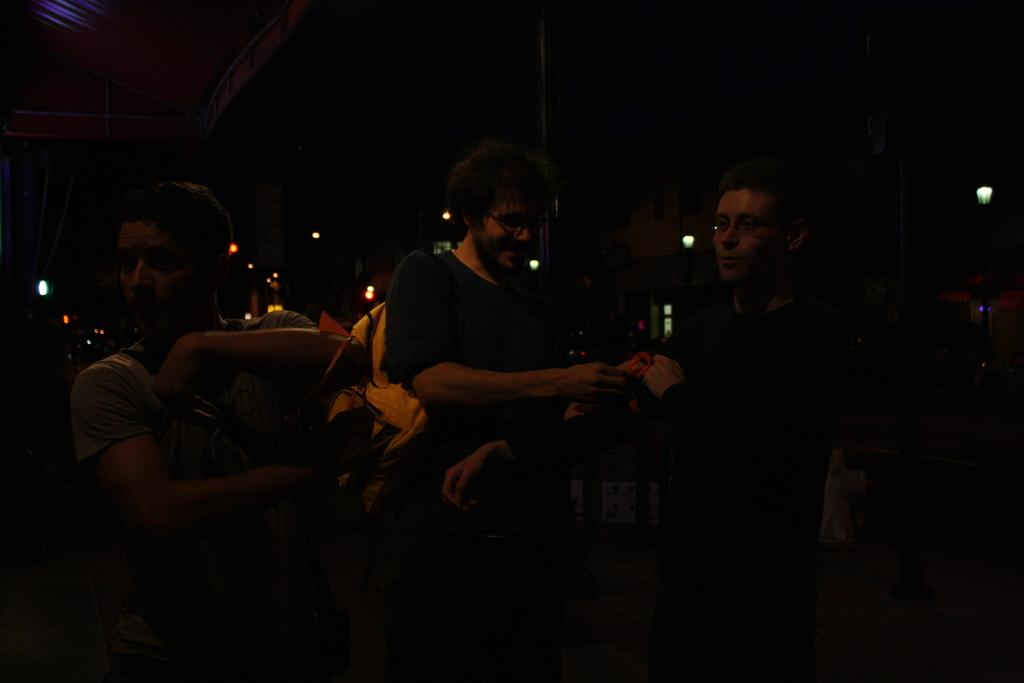How many people are in the image? There are three persons in the image. What are the people wearing? The persons are wearing clothes. Can you describe the position of the person in the middle? The person in the middle is wearing a bag. What color is the bag worn by the person in the middle? The bag is colored yellow. What type of view can be seen from the person's wish in the image? There is no mention of a wish or a view in the image, so it is not possible to answer that question. 